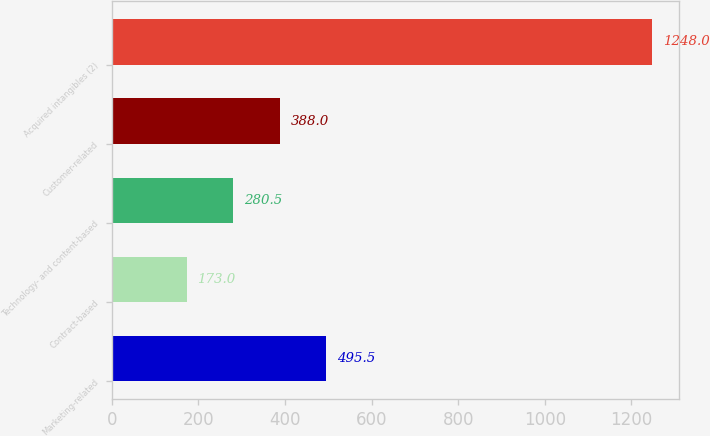Convert chart to OTSL. <chart><loc_0><loc_0><loc_500><loc_500><bar_chart><fcel>Marketing-related<fcel>Contract-based<fcel>Technology- and content-based<fcel>Customer-related<fcel>Acquired intangibles (2)<nl><fcel>495.5<fcel>173<fcel>280.5<fcel>388<fcel>1248<nl></chart> 